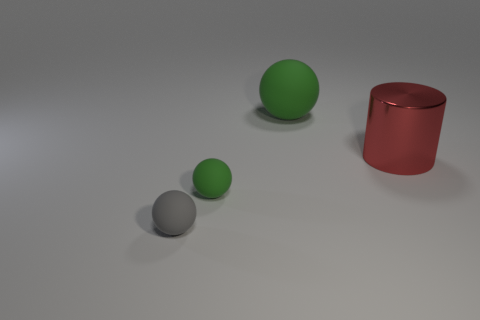Subtract all green matte spheres. How many spheres are left? 1 Add 3 large balls. How many objects exist? 7 Subtract all gray balls. How many balls are left? 2 Subtract all red blocks. How many green spheres are left? 2 Subtract all brown metallic cylinders. Subtract all red metallic cylinders. How many objects are left? 3 Add 3 large red things. How many large red things are left? 4 Add 3 big red rubber cylinders. How many big red rubber cylinders exist? 3 Subtract 0 purple balls. How many objects are left? 4 Subtract all cylinders. How many objects are left? 3 Subtract all blue cylinders. Subtract all gray spheres. How many cylinders are left? 1 